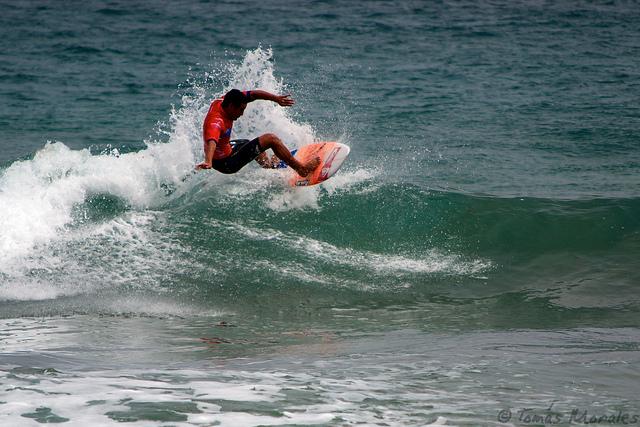What color is the water?
Be succinct. Blue. Is the guy catching a wave?
Concise answer only. Yes. What color is the mans surfboard that is standing?
Give a very brief answer. Orange. What color is the man's shirt?
Concise answer only. Red. Is he going to fall?
Be succinct. Yes. 